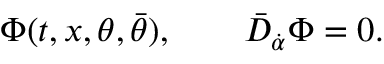Convert formula to latex. <formula><loc_0><loc_0><loc_500><loc_500>\Phi ( t , x , \theta , \bar { \theta } ) , \quad \bar { D } _ { \dot { \alpha } } \Phi = 0 .</formula> 